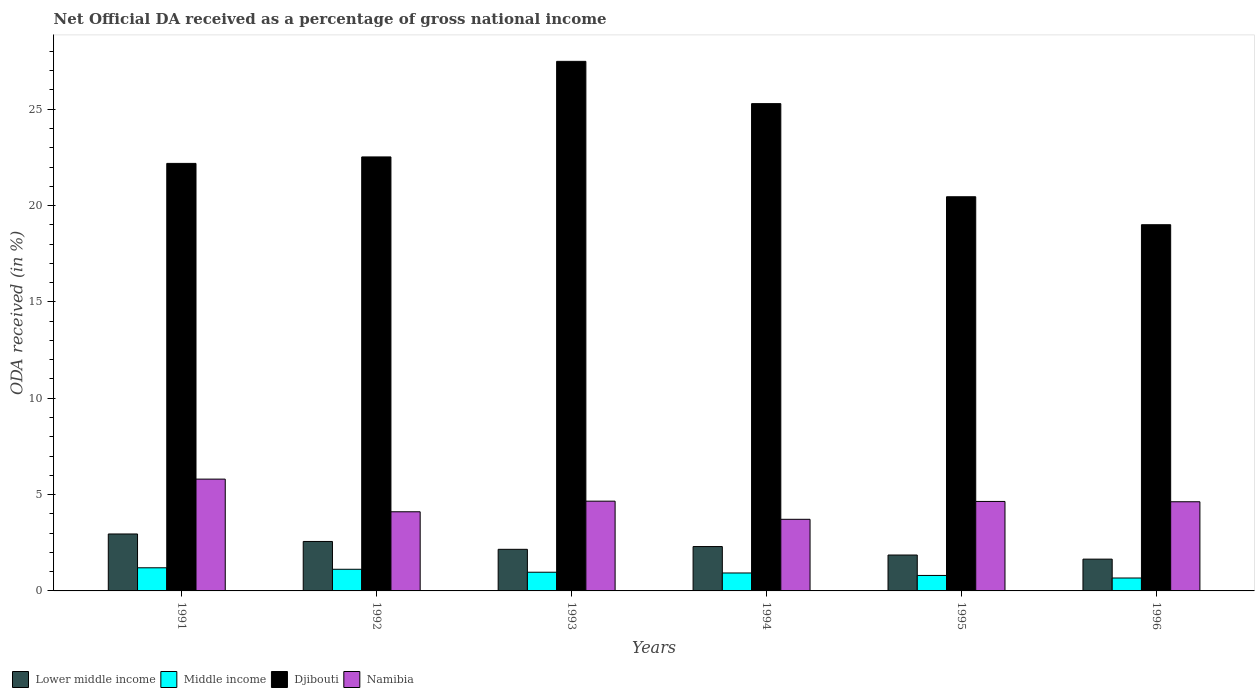Are the number of bars per tick equal to the number of legend labels?
Your response must be concise. Yes. Are the number of bars on each tick of the X-axis equal?
Provide a succinct answer. Yes. How many bars are there on the 4th tick from the right?
Offer a terse response. 4. In how many cases, is the number of bars for a given year not equal to the number of legend labels?
Offer a terse response. 0. What is the net official DA received in Lower middle income in 1993?
Ensure brevity in your answer.  2.16. Across all years, what is the maximum net official DA received in Lower middle income?
Provide a short and direct response. 2.96. Across all years, what is the minimum net official DA received in Lower middle income?
Your answer should be compact. 1.65. In which year was the net official DA received in Lower middle income maximum?
Your answer should be compact. 1991. In which year was the net official DA received in Middle income minimum?
Give a very brief answer. 1996. What is the total net official DA received in Middle income in the graph?
Provide a short and direct response. 5.7. What is the difference between the net official DA received in Middle income in 1991 and that in 1995?
Your answer should be compact. 0.4. What is the difference between the net official DA received in Namibia in 1993 and the net official DA received in Djibouti in 1991?
Provide a succinct answer. -17.53. What is the average net official DA received in Namibia per year?
Provide a short and direct response. 4.59. In the year 1994, what is the difference between the net official DA received in Lower middle income and net official DA received in Middle income?
Give a very brief answer. 1.37. In how many years, is the net official DA received in Lower middle income greater than 11 %?
Give a very brief answer. 0. What is the ratio of the net official DA received in Middle income in 1992 to that in 1994?
Your answer should be compact. 1.21. Is the net official DA received in Namibia in 1993 less than that in 1996?
Provide a succinct answer. No. Is the difference between the net official DA received in Lower middle income in 1994 and 1995 greater than the difference between the net official DA received in Middle income in 1994 and 1995?
Keep it short and to the point. Yes. What is the difference between the highest and the second highest net official DA received in Namibia?
Give a very brief answer. 1.14. What is the difference between the highest and the lowest net official DA received in Namibia?
Ensure brevity in your answer.  2.09. In how many years, is the net official DA received in Namibia greater than the average net official DA received in Namibia taken over all years?
Offer a terse response. 4. What does the 4th bar from the left in 1993 represents?
Give a very brief answer. Namibia. What does the 4th bar from the right in 1992 represents?
Your response must be concise. Lower middle income. Is it the case that in every year, the sum of the net official DA received in Lower middle income and net official DA received in Namibia is greater than the net official DA received in Middle income?
Give a very brief answer. Yes. How many years are there in the graph?
Make the answer very short. 6. What is the difference between two consecutive major ticks on the Y-axis?
Give a very brief answer. 5. Are the values on the major ticks of Y-axis written in scientific E-notation?
Ensure brevity in your answer.  No. Does the graph contain any zero values?
Make the answer very short. No. Does the graph contain grids?
Your answer should be compact. No. Where does the legend appear in the graph?
Offer a terse response. Bottom left. How are the legend labels stacked?
Provide a short and direct response. Horizontal. What is the title of the graph?
Offer a terse response. Net Official DA received as a percentage of gross national income. Does "Moldova" appear as one of the legend labels in the graph?
Offer a very short reply. No. What is the label or title of the Y-axis?
Offer a very short reply. ODA received (in %). What is the ODA received (in %) of Lower middle income in 1991?
Your answer should be very brief. 2.96. What is the ODA received (in %) of Middle income in 1991?
Give a very brief answer. 1.2. What is the ODA received (in %) of Djibouti in 1991?
Provide a succinct answer. 22.19. What is the ODA received (in %) of Namibia in 1991?
Ensure brevity in your answer.  5.8. What is the ODA received (in %) in Lower middle income in 1992?
Give a very brief answer. 2.57. What is the ODA received (in %) of Middle income in 1992?
Offer a terse response. 1.12. What is the ODA received (in %) in Djibouti in 1992?
Ensure brevity in your answer.  22.53. What is the ODA received (in %) of Namibia in 1992?
Your response must be concise. 4.11. What is the ODA received (in %) of Lower middle income in 1993?
Offer a very short reply. 2.16. What is the ODA received (in %) of Middle income in 1993?
Provide a short and direct response. 0.97. What is the ODA received (in %) of Djibouti in 1993?
Keep it short and to the point. 27.49. What is the ODA received (in %) in Namibia in 1993?
Your answer should be compact. 4.66. What is the ODA received (in %) of Lower middle income in 1994?
Offer a terse response. 2.3. What is the ODA received (in %) of Middle income in 1994?
Ensure brevity in your answer.  0.93. What is the ODA received (in %) of Djibouti in 1994?
Your answer should be compact. 25.29. What is the ODA received (in %) in Namibia in 1994?
Offer a terse response. 3.72. What is the ODA received (in %) of Lower middle income in 1995?
Ensure brevity in your answer.  1.86. What is the ODA received (in %) of Middle income in 1995?
Give a very brief answer. 0.8. What is the ODA received (in %) in Djibouti in 1995?
Provide a succinct answer. 20.46. What is the ODA received (in %) in Namibia in 1995?
Offer a terse response. 4.64. What is the ODA received (in %) in Lower middle income in 1996?
Your answer should be compact. 1.65. What is the ODA received (in %) of Middle income in 1996?
Your answer should be compact. 0.67. What is the ODA received (in %) in Djibouti in 1996?
Ensure brevity in your answer.  19.01. What is the ODA received (in %) in Namibia in 1996?
Offer a very short reply. 4.63. Across all years, what is the maximum ODA received (in %) of Lower middle income?
Your answer should be compact. 2.96. Across all years, what is the maximum ODA received (in %) in Middle income?
Ensure brevity in your answer.  1.2. Across all years, what is the maximum ODA received (in %) in Djibouti?
Your response must be concise. 27.49. Across all years, what is the maximum ODA received (in %) in Namibia?
Ensure brevity in your answer.  5.8. Across all years, what is the minimum ODA received (in %) in Lower middle income?
Your answer should be compact. 1.65. Across all years, what is the minimum ODA received (in %) in Middle income?
Provide a short and direct response. 0.67. Across all years, what is the minimum ODA received (in %) of Djibouti?
Offer a very short reply. 19.01. Across all years, what is the minimum ODA received (in %) of Namibia?
Make the answer very short. 3.72. What is the total ODA received (in %) in Lower middle income in the graph?
Offer a terse response. 13.5. What is the total ODA received (in %) of Middle income in the graph?
Make the answer very short. 5.7. What is the total ODA received (in %) of Djibouti in the graph?
Your answer should be compact. 136.96. What is the total ODA received (in %) of Namibia in the graph?
Offer a very short reply. 27.56. What is the difference between the ODA received (in %) in Lower middle income in 1991 and that in 1992?
Make the answer very short. 0.39. What is the difference between the ODA received (in %) in Middle income in 1991 and that in 1992?
Give a very brief answer. 0.08. What is the difference between the ODA received (in %) of Djibouti in 1991 and that in 1992?
Keep it short and to the point. -0.34. What is the difference between the ODA received (in %) of Namibia in 1991 and that in 1992?
Offer a very short reply. 1.7. What is the difference between the ODA received (in %) in Lower middle income in 1991 and that in 1993?
Give a very brief answer. 0.8. What is the difference between the ODA received (in %) of Middle income in 1991 and that in 1993?
Offer a very short reply. 0.23. What is the difference between the ODA received (in %) in Djibouti in 1991 and that in 1993?
Your response must be concise. -5.3. What is the difference between the ODA received (in %) in Namibia in 1991 and that in 1993?
Offer a very short reply. 1.14. What is the difference between the ODA received (in %) of Lower middle income in 1991 and that in 1994?
Your response must be concise. 0.65. What is the difference between the ODA received (in %) of Middle income in 1991 and that in 1994?
Your answer should be very brief. 0.27. What is the difference between the ODA received (in %) in Djibouti in 1991 and that in 1994?
Your answer should be compact. -3.1. What is the difference between the ODA received (in %) of Namibia in 1991 and that in 1994?
Offer a terse response. 2.09. What is the difference between the ODA received (in %) in Lower middle income in 1991 and that in 1995?
Give a very brief answer. 1.09. What is the difference between the ODA received (in %) in Middle income in 1991 and that in 1995?
Your answer should be very brief. 0.4. What is the difference between the ODA received (in %) in Djibouti in 1991 and that in 1995?
Ensure brevity in your answer.  1.73. What is the difference between the ODA received (in %) in Namibia in 1991 and that in 1995?
Ensure brevity in your answer.  1.16. What is the difference between the ODA received (in %) of Lower middle income in 1991 and that in 1996?
Your answer should be compact. 1.31. What is the difference between the ODA received (in %) in Middle income in 1991 and that in 1996?
Provide a short and direct response. 0.53. What is the difference between the ODA received (in %) in Djibouti in 1991 and that in 1996?
Make the answer very short. 3.18. What is the difference between the ODA received (in %) in Namibia in 1991 and that in 1996?
Your answer should be very brief. 1.18. What is the difference between the ODA received (in %) in Lower middle income in 1992 and that in 1993?
Ensure brevity in your answer.  0.41. What is the difference between the ODA received (in %) in Middle income in 1992 and that in 1993?
Your response must be concise. 0.15. What is the difference between the ODA received (in %) of Djibouti in 1992 and that in 1993?
Your answer should be very brief. -4.96. What is the difference between the ODA received (in %) in Namibia in 1992 and that in 1993?
Your answer should be compact. -0.55. What is the difference between the ODA received (in %) in Lower middle income in 1992 and that in 1994?
Provide a succinct answer. 0.26. What is the difference between the ODA received (in %) of Middle income in 1992 and that in 1994?
Give a very brief answer. 0.19. What is the difference between the ODA received (in %) in Djibouti in 1992 and that in 1994?
Provide a succinct answer. -2.77. What is the difference between the ODA received (in %) in Namibia in 1992 and that in 1994?
Your answer should be compact. 0.39. What is the difference between the ODA received (in %) of Lower middle income in 1992 and that in 1995?
Provide a short and direct response. 0.7. What is the difference between the ODA received (in %) of Middle income in 1992 and that in 1995?
Keep it short and to the point. 0.32. What is the difference between the ODA received (in %) of Djibouti in 1992 and that in 1995?
Offer a terse response. 2.07. What is the difference between the ODA received (in %) in Namibia in 1992 and that in 1995?
Your answer should be compact. -0.54. What is the difference between the ODA received (in %) in Lower middle income in 1992 and that in 1996?
Provide a succinct answer. 0.92. What is the difference between the ODA received (in %) in Middle income in 1992 and that in 1996?
Provide a succinct answer. 0.45. What is the difference between the ODA received (in %) of Djibouti in 1992 and that in 1996?
Offer a terse response. 3.52. What is the difference between the ODA received (in %) in Namibia in 1992 and that in 1996?
Your response must be concise. -0.52. What is the difference between the ODA received (in %) of Lower middle income in 1993 and that in 1994?
Provide a succinct answer. -0.14. What is the difference between the ODA received (in %) in Middle income in 1993 and that in 1994?
Offer a terse response. 0.04. What is the difference between the ODA received (in %) in Djibouti in 1993 and that in 1994?
Offer a very short reply. 2.19. What is the difference between the ODA received (in %) of Lower middle income in 1993 and that in 1995?
Provide a short and direct response. 0.3. What is the difference between the ODA received (in %) in Middle income in 1993 and that in 1995?
Offer a very short reply. 0.17. What is the difference between the ODA received (in %) in Djibouti in 1993 and that in 1995?
Ensure brevity in your answer.  7.03. What is the difference between the ODA received (in %) in Namibia in 1993 and that in 1995?
Provide a short and direct response. 0.01. What is the difference between the ODA received (in %) in Lower middle income in 1993 and that in 1996?
Your answer should be very brief. 0.51. What is the difference between the ODA received (in %) in Djibouti in 1993 and that in 1996?
Make the answer very short. 8.48. What is the difference between the ODA received (in %) in Namibia in 1993 and that in 1996?
Provide a succinct answer. 0.03. What is the difference between the ODA received (in %) in Lower middle income in 1994 and that in 1995?
Keep it short and to the point. 0.44. What is the difference between the ODA received (in %) in Middle income in 1994 and that in 1995?
Offer a terse response. 0.13. What is the difference between the ODA received (in %) of Djibouti in 1994 and that in 1995?
Your response must be concise. 4.83. What is the difference between the ODA received (in %) in Namibia in 1994 and that in 1995?
Keep it short and to the point. -0.93. What is the difference between the ODA received (in %) of Lower middle income in 1994 and that in 1996?
Ensure brevity in your answer.  0.65. What is the difference between the ODA received (in %) in Middle income in 1994 and that in 1996?
Offer a very short reply. 0.26. What is the difference between the ODA received (in %) in Djibouti in 1994 and that in 1996?
Give a very brief answer. 6.29. What is the difference between the ODA received (in %) in Namibia in 1994 and that in 1996?
Your answer should be compact. -0.91. What is the difference between the ODA received (in %) of Lower middle income in 1995 and that in 1996?
Offer a very short reply. 0.21. What is the difference between the ODA received (in %) of Middle income in 1995 and that in 1996?
Make the answer very short. 0.13. What is the difference between the ODA received (in %) of Djibouti in 1995 and that in 1996?
Provide a short and direct response. 1.45. What is the difference between the ODA received (in %) of Namibia in 1995 and that in 1996?
Provide a short and direct response. 0.02. What is the difference between the ODA received (in %) in Lower middle income in 1991 and the ODA received (in %) in Middle income in 1992?
Your answer should be compact. 1.83. What is the difference between the ODA received (in %) in Lower middle income in 1991 and the ODA received (in %) in Djibouti in 1992?
Your answer should be very brief. -19.57. What is the difference between the ODA received (in %) in Lower middle income in 1991 and the ODA received (in %) in Namibia in 1992?
Your response must be concise. -1.15. What is the difference between the ODA received (in %) of Middle income in 1991 and the ODA received (in %) of Djibouti in 1992?
Provide a short and direct response. -21.33. What is the difference between the ODA received (in %) of Middle income in 1991 and the ODA received (in %) of Namibia in 1992?
Make the answer very short. -2.91. What is the difference between the ODA received (in %) of Djibouti in 1991 and the ODA received (in %) of Namibia in 1992?
Your answer should be compact. 18.08. What is the difference between the ODA received (in %) in Lower middle income in 1991 and the ODA received (in %) in Middle income in 1993?
Make the answer very short. 1.99. What is the difference between the ODA received (in %) in Lower middle income in 1991 and the ODA received (in %) in Djibouti in 1993?
Make the answer very short. -24.53. What is the difference between the ODA received (in %) in Lower middle income in 1991 and the ODA received (in %) in Namibia in 1993?
Provide a succinct answer. -1.7. What is the difference between the ODA received (in %) in Middle income in 1991 and the ODA received (in %) in Djibouti in 1993?
Provide a succinct answer. -26.29. What is the difference between the ODA received (in %) of Middle income in 1991 and the ODA received (in %) of Namibia in 1993?
Ensure brevity in your answer.  -3.46. What is the difference between the ODA received (in %) of Djibouti in 1991 and the ODA received (in %) of Namibia in 1993?
Provide a short and direct response. 17.53. What is the difference between the ODA received (in %) in Lower middle income in 1991 and the ODA received (in %) in Middle income in 1994?
Make the answer very short. 2.02. What is the difference between the ODA received (in %) of Lower middle income in 1991 and the ODA received (in %) of Djibouti in 1994?
Provide a short and direct response. -22.34. What is the difference between the ODA received (in %) in Lower middle income in 1991 and the ODA received (in %) in Namibia in 1994?
Give a very brief answer. -0.76. What is the difference between the ODA received (in %) in Middle income in 1991 and the ODA received (in %) in Djibouti in 1994?
Give a very brief answer. -24.09. What is the difference between the ODA received (in %) in Middle income in 1991 and the ODA received (in %) in Namibia in 1994?
Give a very brief answer. -2.52. What is the difference between the ODA received (in %) of Djibouti in 1991 and the ODA received (in %) of Namibia in 1994?
Offer a very short reply. 18.47. What is the difference between the ODA received (in %) of Lower middle income in 1991 and the ODA received (in %) of Middle income in 1995?
Offer a terse response. 2.15. What is the difference between the ODA received (in %) in Lower middle income in 1991 and the ODA received (in %) in Djibouti in 1995?
Your response must be concise. -17.5. What is the difference between the ODA received (in %) in Lower middle income in 1991 and the ODA received (in %) in Namibia in 1995?
Your answer should be very brief. -1.69. What is the difference between the ODA received (in %) of Middle income in 1991 and the ODA received (in %) of Djibouti in 1995?
Provide a short and direct response. -19.26. What is the difference between the ODA received (in %) of Middle income in 1991 and the ODA received (in %) of Namibia in 1995?
Provide a short and direct response. -3.44. What is the difference between the ODA received (in %) in Djibouti in 1991 and the ODA received (in %) in Namibia in 1995?
Your answer should be compact. 17.55. What is the difference between the ODA received (in %) of Lower middle income in 1991 and the ODA received (in %) of Middle income in 1996?
Your answer should be very brief. 2.29. What is the difference between the ODA received (in %) in Lower middle income in 1991 and the ODA received (in %) in Djibouti in 1996?
Ensure brevity in your answer.  -16.05. What is the difference between the ODA received (in %) in Lower middle income in 1991 and the ODA received (in %) in Namibia in 1996?
Your response must be concise. -1.67. What is the difference between the ODA received (in %) in Middle income in 1991 and the ODA received (in %) in Djibouti in 1996?
Keep it short and to the point. -17.81. What is the difference between the ODA received (in %) of Middle income in 1991 and the ODA received (in %) of Namibia in 1996?
Your answer should be very brief. -3.43. What is the difference between the ODA received (in %) of Djibouti in 1991 and the ODA received (in %) of Namibia in 1996?
Your answer should be very brief. 17.56. What is the difference between the ODA received (in %) in Lower middle income in 1992 and the ODA received (in %) in Middle income in 1993?
Offer a terse response. 1.6. What is the difference between the ODA received (in %) of Lower middle income in 1992 and the ODA received (in %) of Djibouti in 1993?
Your response must be concise. -24.92. What is the difference between the ODA received (in %) in Lower middle income in 1992 and the ODA received (in %) in Namibia in 1993?
Your response must be concise. -2.09. What is the difference between the ODA received (in %) in Middle income in 1992 and the ODA received (in %) in Djibouti in 1993?
Your answer should be compact. -26.36. What is the difference between the ODA received (in %) of Middle income in 1992 and the ODA received (in %) of Namibia in 1993?
Offer a very short reply. -3.54. What is the difference between the ODA received (in %) in Djibouti in 1992 and the ODA received (in %) in Namibia in 1993?
Your response must be concise. 17.87. What is the difference between the ODA received (in %) of Lower middle income in 1992 and the ODA received (in %) of Middle income in 1994?
Your response must be concise. 1.64. What is the difference between the ODA received (in %) in Lower middle income in 1992 and the ODA received (in %) in Djibouti in 1994?
Give a very brief answer. -22.73. What is the difference between the ODA received (in %) of Lower middle income in 1992 and the ODA received (in %) of Namibia in 1994?
Ensure brevity in your answer.  -1.15. What is the difference between the ODA received (in %) in Middle income in 1992 and the ODA received (in %) in Djibouti in 1994?
Provide a short and direct response. -24.17. What is the difference between the ODA received (in %) of Middle income in 1992 and the ODA received (in %) of Namibia in 1994?
Your answer should be compact. -2.59. What is the difference between the ODA received (in %) of Djibouti in 1992 and the ODA received (in %) of Namibia in 1994?
Your answer should be compact. 18.81. What is the difference between the ODA received (in %) in Lower middle income in 1992 and the ODA received (in %) in Middle income in 1995?
Provide a short and direct response. 1.76. What is the difference between the ODA received (in %) in Lower middle income in 1992 and the ODA received (in %) in Djibouti in 1995?
Make the answer very short. -17.89. What is the difference between the ODA received (in %) in Lower middle income in 1992 and the ODA received (in %) in Namibia in 1995?
Offer a very short reply. -2.08. What is the difference between the ODA received (in %) of Middle income in 1992 and the ODA received (in %) of Djibouti in 1995?
Your answer should be compact. -19.34. What is the difference between the ODA received (in %) of Middle income in 1992 and the ODA received (in %) of Namibia in 1995?
Keep it short and to the point. -3.52. What is the difference between the ODA received (in %) in Djibouti in 1992 and the ODA received (in %) in Namibia in 1995?
Offer a terse response. 17.88. What is the difference between the ODA received (in %) in Lower middle income in 1992 and the ODA received (in %) in Middle income in 1996?
Your response must be concise. 1.9. What is the difference between the ODA received (in %) of Lower middle income in 1992 and the ODA received (in %) of Djibouti in 1996?
Your response must be concise. -16.44. What is the difference between the ODA received (in %) in Lower middle income in 1992 and the ODA received (in %) in Namibia in 1996?
Offer a very short reply. -2.06. What is the difference between the ODA received (in %) in Middle income in 1992 and the ODA received (in %) in Djibouti in 1996?
Keep it short and to the point. -17.88. What is the difference between the ODA received (in %) in Middle income in 1992 and the ODA received (in %) in Namibia in 1996?
Your answer should be compact. -3.5. What is the difference between the ODA received (in %) of Djibouti in 1992 and the ODA received (in %) of Namibia in 1996?
Give a very brief answer. 17.9. What is the difference between the ODA received (in %) in Lower middle income in 1993 and the ODA received (in %) in Middle income in 1994?
Keep it short and to the point. 1.23. What is the difference between the ODA received (in %) in Lower middle income in 1993 and the ODA received (in %) in Djibouti in 1994?
Provide a succinct answer. -23.13. What is the difference between the ODA received (in %) of Lower middle income in 1993 and the ODA received (in %) of Namibia in 1994?
Provide a succinct answer. -1.56. What is the difference between the ODA received (in %) in Middle income in 1993 and the ODA received (in %) in Djibouti in 1994?
Your answer should be very brief. -24.32. What is the difference between the ODA received (in %) of Middle income in 1993 and the ODA received (in %) of Namibia in 1994?
Offer a terse response. -2.75. What is the difference between the ODA received (in %) of Djibouti in 1993 and the ODA received (in %) of Namibia in 1994?
Ensure brevity in your answer.  23.77. What is the difference between the ODA received (in %) in Lower middle income in 1993 and the ODA received (in %) in Middle income in 1995?
Offer a terse response. 1.36. What is the difference between the ODA received (in %) of Lower middle income in 1993 and the ODA received (in %) of Djibouti in 1995?
Provide a succinct answer. -18.3. What is the difference between the ODA received (in %) of Lower middle income in 1993 and the ODA received (in %) of Namibia in 1995?
Ensure brevity in your answer.  -2.48. What is the difference between the ODA received (in %) of Middle income in 1993 and the ODA received (in %) of Djibouti in 1995?
Provide a short and direct response. -19.49. What is the difference between the ODA received (in %) in Middle income in 1993 and the ODA received (in %) in Namibia in 1995?
Give a very brief answer. -3.67. What is the difference between the ODA received (in %) of Djibouti in 1993 and the ODA received (in %) of Namibia in 1995?
Provide a succinct answer. 22.84. What is the difference between the ODA received (in %) of Lower middle income in 1993 and the ODA received (in %) of Middle income in 1996?
Keep it short and to the point. 1.49. What is the difference between the ODA received (in %) of Lower middle income in 1993 and the ODA received (in %) of Djibouti in 1996?
Provide a short and direct response. -16.85. What is the difference between the ODA received (in %) in Lower middle income in 1993 and the ODA received (in %) in Namibia in 1996?
Offer a very short reply. -2.47. What is the difference between the ODA received (in %) in Middle income in 1993 and the ODA received (in %) in Djibouti in 1996?
Your answer should be very brief. -18.04. What is the difference between the ODA received (in %) of Middle income in 1993 and the ODA received (in %) of Namibia in 1996?
Provide a succinct answer. -3.66. What is the difference between the ODA received (in %) of Djibouti in 1993 and the ODA received (in %) of Namibia in 1996?
Your response must be concise. 22.86. What is the difference between the ODA received (in %) of Lower middle income in 1994 and the ODA received (in %) of Middle income in 1995?
Your answer should be very brief. 1.5. What is the difference between the ODA received (in %) of Lower middle income in 1994 and the ODA received (in %) of Djibouti in 1995?
Ensure brevity in your answer.  -18.16. What is the difference between the ODA received (in %) of Lower middle income in 1994 and the ODA received (in %) of Namibia in 1995?
Offer a very short reply. -2.34. What is the difference between the ODA received (in %) of Middle income in 1994 and the ODA received (in %) of Djibouti in 1995?
Provide a short and direct response. -19.53. What is the difference between the ODA received (in %) of Middle income in 1994 and the ODA received (in %) of Namibia in 1995?
Offer a terse response. -3.71. What is the difference between the ODA received (in %) of Djibouti in 1994 and the ODA received (in %) of Namibia in 1995?
Make the answer very short. 20.65. What is the difference between the ODA received (in %) in Lower middle income in 1994 and the ODA received (in %) in Middle income in 1996?
Your response must be concise. 1.63. What is the difference between the ODA received (in %) of Lower middle income in 1994 and the ODA received (in %) of Djibouti in 1996?
Offer a very short reply. -16.7. What is the difference between the ODA received (in %) of Lower middle income in 1994 and the ODA received (in %) of Namibia in 1996?
Provide a short and direct response. -2.32. What is the difference between the ODA received (in %) in Middle income in 1994 and the ODA received (in %) in Djibouti in 1996?
Keep it short and to the point. -18.08. What is the difference between the ODA received (in %) in Middle income in 1994 and the ODA received (in %) in Namibia in 1996?
Offer a terse response. -3.7. What is the difference between the ODA received (in %) in Djibouti in 1994 and the ODA received (in %) in Namibia in 1996?
Offer a very short reply. 20.66. What is the difference between the ODA received (in %) in Lower middle income in 1995 and the ODA received (in %) in Middle income in 1996?
Provide a succinct answer. 1.19. What is the difference between the ODA received (in %) of Lower middle income in 1995 and the ODA received (in %) of Djibouti in 1996?
Offer a very short reply. -17.14. What is the difference between the ODA received (in %) in Lower middle income in 1995 and the ODA received (in %) in Namibia in 1996?
Keep it short and to the point. -2.76. What is the difference between the ODA received (in %) of Middle income in 1995 and the ODA received (in %) of Djibouti in 1996?
Provide a succinct answer. -18.2. What is the difference between the ODA received (in %) of Middle income in 1995 and the ODA received (in %) of Namibia in 1996?
Give a very brief answer. -3.82. What is the difference between the ODA received (in %) in Djibouti in 1995 and the ODA received (in %) in Namibia in 1996?
Make the answer very short. 15.83. What is the average ODA received (in %) of Lower middle income per year?
Offer a terse response. 2.25. What is the average ODA received (in %) of Middle income per year?
Your answer should be very brief. 0.95. What is the average ODA received (in %) in Djibouti per year?
Offer a very short reply. 22.83. What is the average ODA received (in %) in Namibia per year?
Keep it short and to the point. 4.59. In the year 1991, what is the difference between the ODA received (in %) in Lower middle income and ODA received (in %) in Middle income?
Offer a terse response. 1.76. In the year 1991, what is the difference between the ODA received (in %) in Lower middle income and ODA received (in %) in Djibouti?
Your response must be concise. -19.23. In the year 1991, what is the difference between the ODA received (in %) in Lower middle income and ODA received (in %) in Namibia?
Keep it short and to the point. -2.85. In the year 1991, what is the difference between the ODA received (in %) in Middle income and ODA received (in %) in Djibouti?
Offer a terse response. -20.99. In the year 1991, what is the difference between the ODA received (in %) of Middle income and ODA received (in %) of Namibia?
Offer a very short reply. -4.6. In the year 1991, what is the difference between the ODA received (in %) of Djibouti and ODA received (in %) of Namibia?
Give a very brief answer. 16.39. In the year 1992, what is the difference between the ODA received (in %) of Lower middle income and ODA received (in %) of Middle income?
Give a very brief answer. 1.44. In the year 1992, what is the difference between the ODA received (in %) of Lower middle income and ODA received (in %) of Djibouti?
Keep it short and to the point. -19.96. In the year 1992, what is the difference between the ODA received (in %) in Lower middle income and ODA received (in %) in Namibia?
Provide a short and direct response. -1.54. In the year 1992, what is the difference between the ODA received (in %) of Middle income and ODA received (in %) of Djibouti?
Your answer should be compact. -21.4. In the year 1992, what is the difference between the ODA received (in %) in Middle income and ODA received (in %) in Namibia?
Provide a short and direct response. -2.98. In the year 1992, what is the difference between the ODA received (in %) of Djibouti and ODA received (in %) of Namibia?
Your answer should be compact. 18.42. In the year 1993, what is the difference between the ODA received (in %) of Lower middle income and ODA received (in %) of Middle income?
Keep it short and to the point. 1.19. In the year 1993, what is the difference between the ODA received (in %) in Lower middle income and ODA received (in %) in Djibouti?
Your response must be concise. -25.33. In the year 1993, what is the difference between the ODA received (in %) in Lower middle income and ODA received (in %) in Namibia?
Offer a very short reply. -2.5. In the year 1993, what is the difference between the ODA received (in %) in Middle income and ODA received (in %) in Djibouti?
Keep it short and to the point. -26.52. In the year 1993, what is the difference between the ODA received (in %) of Middle income and ODA received (in %) of Namibia?
Provide a short and direct response. -3.69. In the year 1993, what is the difference between the ODA received (in %) of Djibouti and ODA received (in %) of Namibia?
Provide a short and direct response. 22.83. In the year 1994, what is the difference between the ODA received (in %) of Lower middle income and ODA received (in %) of Middle income?
Provide a succinct answer. 1.37. In the year 1994, what is the difference between the ODA received (in %) of Lower middle income and ODA received (in %) of Djibouti?
Provide a short and direct response. -22.99. In the year 1994, what is the difference between the ODA received (in %) in Lower middle income and ODA received (in %) in Namibia?
Offer a terse response. -1.41. In the year 1994, what is the difference between the ODA received (in %) in Middle income and ODA received (in %) in Djibouti?
Make the answer very short. -24.36. In the year 1994, what is the difference between the ODA received (in %) in Middle income and ODA received (in %) in Namibia?
Offer a terse response. -2.79. In the year 1994, what is the difference between the ODA received (in %) in Djibouti and ODA received (in %) in Namibia?
Your answer should be compact. 21.58. In the year 1995, what is the difference between the ODA received (in %) of Lower middle income and ODA received (in %) of Middle income?
Ensure brevity in your answer.  1.06. In the year 1995, what is the difference between the ODA received (in %) in Lower middle income and ODA received (in %) in Djibouti?
Provide a short and direct response. -18.6. In the year 1995, what is the difference between the ODA received (in %) in Lower middle income and ODA received (in %) in Namibia?
Ensure brevity in your answer.  -2.78. In the year 1995, what is the difference between the ODA received (in %) in Middle income and ODA received (in %) in Djibouti?
Make the answer very short. -19.66. In the year 1995, what is the difference between the ODA received (in %) of Middle income and ODA received (in %) of Namibia?
Ensure brevity in your answer.  -3.84. In the year 1995, what is the difference between the ODA received (in %) of Djibouti and ODA received (in %) of Namibia?
Provide a short and direct response. 15.81. In the year 1996, what is the difference between the ODA received (in %) of Lower middle income and ODA received (in %) of Middle income?
Provide a succinct answer. 0.98. In the year 1996, what is the difference between the ODA received (in %) of Lower middle income and ODA received (in %) of Djibouti?
Your response must be concise. -17.36. In the year 1996, what is the difference between the ODA received (in %) of Lower middle income and ODA received (in %) of Namibia?
Provide a short and direct response. -2.98. In the year 1996, what is the difference between the ODA received (in %) of Middle income and ODA received (in %) of Djibouti?
Make the answer very short. -18.34. In the year 1996, what is the difference between the ODA received (in %) in Middle income and ODA received (in %) in Namibia?
Your answer should be compact. -3.96. In the year 1996, what is the difference between the ODA received (in %) of Djibouti and ODA received (in %) of Namibia?
Offer a very short reply. 14.38. What is the ratio of the ODA received (in %) of Lower middle income in 1991 to that in 1992?
Make the answer very short. 1.15. What is the ratio of the ODA received (in %) of Middle income in 1991 to that in 1992?
Provide a succinct answer. 1.07. What is the ratio of the ODA received (in %) in Djibouti in 1991 to that in 1992?
Ensure brevity in your answer.  0.99. What is the ratio of the ODA received (in %) in Namibia in 1991 to that in 1992?
Ensure brevity in your answer.  1.41. What is the ratio of the ODA received (in %) of Lower middle income in 1991 to that in 1993?
Ensure brevity in your answer.  1.37. What is the ratio of the ODA received (in %) of Middle income in 1991 to that in 1993?
Provide a succinct answer. 1.24. What is the ratio of the ODA received (in %) of Djibouti in 1991 to that in 1993?
Ensure brevity in your answer.  0.81. What is the ratio of the ODA received (in %) of Namibia in 1991 to that in 1993?
Keep it short and to the point. 1.25. What is the ratio of the ODA received (in %) in Lower middle income in 1991 to that in 1994?
Offer a very short reply. 1.28. What is the ratio of the ODA received (in %) in Middle income in 1991 to that in 1994?
Make the answer very short. 1.29. What is the ratio of the ODA received (in %) of Djibouti in 1991 to that in 1994?
Your response must be concise. 0.88. What is the ratio of the ODA received (in %) in Namibia in 1991 to that in 1994?
Provide a short and direct response. 1.56. What is the ratio of the ODA received (in %) of Lower middle income in 1991 to that in 1995?
Provide a short and direct response. 1.59. What is the ratio of the ODA received (in %) of Middle income in 1991 to that in 1995?
Ensure brevity in your answer.  1.49. What is the ratio of the ODA received (in %) in Djibouti in 1991 to that in 1995?
Give a very brief answer. 1.08. What is the ratio of the ODA received (in %) in Namibia in 1991 to that in 1995?
Ensure brevity in your answer.  1.25. What is the ratio of the ODA received (in %) of Lower middle income in 1991 to that in 1996?
Your response must be concise. 1.79. What is the ratio of the ODA received (in %) of Middle income in 1991 to that in 1996?
Give a very brief answer. 1.79. What is the ratio of the ODA received (in %) in Djibouti in 1991 to that in 1996?
Your answer should be compact. 1.17. What is the ratio of the ODA received (in %) in Namibia in 1991 to that in 1996?
Give a very brief answer. 1.25. What is the ratio of the ODA received (in %) in Lower middle income in 1992 to that in 1993?
Ensure brevity in your answer.  1.19. What is the ratio of the ODA received (in %) of Middle income in 1992 to that in 1993?
Provide a short and direct response. 1.16. What is the ratio of the ODA received (in %) in Djibouti in 1992 to that in 1993?
Offer a very short reply. 0.82. What is the ratio of the ODA received (in %) in Namibia in 1992 to that in 1993?
Your answer should be compact. 0.88. What is the ratio of the ODA received (in %) in Lower middle income in 1992 to that in 1994?
Provide a succinct answer. 1.11. What is the ratio of the ODA received (in %) of Middle income in 1992 to that in 1994?
Your answer should be very brief. 1.21. What is the ratio of the ODA received (in %) of Djibouti in 1992 to that in 1994?
Your answer should be compact. 0.89. What is the ratio of the ODA received (in %) of Namibia in 1992 to that in 1994?
Ensure brevity in your answer.  1.1. What is the ratio of the ODA received (in %) of Lower middle income in 1992 to that in 1995?
Your response must be concise. 1.38. What is the ratio of the ODA received (in %) of Middle income in 1992 to that in 1995?
Offer a very short reply. 1.4. What is the ratio of the ODA received (in %) in Djibouti in 1992 to that in 1995?
Your answer should be very brief. 1.1. What is the ratio of the ODA received (in %) of Namibia in 1992 to that in 1995?
Give a very brief answer. 0.88. What is the ratio of the ODA received (in %) of Lower middle income in 1992 to that in 1996?
Provide a succinct answer. 1.56. What is the ratio of the ODA received (in %) of Middle income in 1992 to that in 1996?
Keep it short and to the point. 1.68. What is the ratio of the ODA received (in %) of Djibouti in 1992 to that in 1996?
Provide a short and direct response. 1.19. What is the ratio of the ODA received (in %) in Namibia in 1992 to that in 1996?
Your answer should be compact. 0.89. What is the ratio of the ODA received (in %) of Lower middle income in 1993 to that in 1994?
Provide a short and direct response. 0.94. What is the ratio of the ODA received (in %) in Middle income in 1993 to that in 1994?
Offer a terse response. 1.04. What is the ratio of the ODA received (in %) of Djibouti in 1993 to that in 1994?
Your answer should be compact. 1.09. What is the ratio of the ODA received (in %) in Namibia in 1993 to that in 1994?
Your answer should be very brief. 1.25. What is the ratio of the ODA received (in %) of Lower middle income in 1993 to that in 1995?
Your answer should be very brief. 1.16. What is the ratio of the ODA received (in %) in Middle income in 1993 to that in 1995?
Provide a short and direct response. 1.21. What is the ratio of the ODA received (in %) of Djibouti in 1993 to that in 1995?
Offer a very short reply. 1.34. What is the ratio of the ODA received (in %) of Namibia in 1993 to that in 1995?
Provide a short and direct response. 1. What is the ratio of the ODA received (in %) in Lower middle income in 1993 to that in 1996?
Your answer should be very brief. 1.31. What is the ratio of the ODA received (in %) in Middle income in 1993 to that in 1996?
Give a very brief answer. 1.45. What is the ratio of the ODA received (in %) in Djibouti in 1993 to that in 1996?
Provide a succinct answer. 1.45. What is the ratio of the ODA received (in %) in Lower middle income in 1994 to that in 1995?
Keep it short and to the point. 1.24. What is the ratio of the ODA received (in %) of Middle income in 1994 to that in 1995?
Your answer should be compact. 1.16. What is the ratio of the ODA received (in %) in Djibouti in 1994 to that in 1995?
Ensure brevity in your answer.  1.24. What is the ratio of the ODA received (in %) in Namibia in 1994 to that in 1995?
Offer a terse response. 0.8. What is the ratio of the ODA received (in %) in Lower middle income in 1994 to that in 1996?
Offer a very short reply. 1.4. What is the ratio of the ODA received (in %) of Middle income in 1994 to that in 1996?
Provide a short and direct response. 1.39. What is the ratio of the ODA received (in %) of Djibouti in 1994 to that in 1996?
Provide a succinct answer. 1.33. What is the ratio of the ODA received (in %) of Namibia in 1994 to that in 1996?
Keep it short and to the point. 0.8. What is the ratio of the ODA received (in %) in Lower middle income in 1995 to that in 1996?
Your response must be concise. 1.13. What is the ratio of the ODA received (in %) of Middle income in 1995 to that in 1996?
Your answer should be compact. 1.2. What is the ratio of the ODA received (in %) of Djibouti in 1995 to that in 1996?
Keep it short and to the point. 1.08. What is the difference between the highest and the second highest ODA received (in %) in Lower middle income?
Give a very brief answer. 0.39. What is the difference between the highest and the second highest ODA received (in %) of Middle income?
Your answer should be compact. 0.08. What is the difference between the highest and the second highest ODA received (in %) of Djibouti?
Offer a very short reply. 2.19. What is the difference between the highest and the second highest ODA received (in %) of Namibia?
Ensure brevity in your answer.  1.14. What is the difference between the highest and the lowest ODA received (in %) in Lower middle income?
Make the answer very short. 1.31. What is the difference between the highest and the lowest ODA received (in %) in Middle income?
Offer a very short reply. 0.53. What is the difference between the highest and the lowest ODA received (in %) of Djibouti?
Give a very brief answer. 8.48. What is the difference between the highest and the lowest ODA received (in %) in Namibia?
Your answer should be compact. 2.09. 